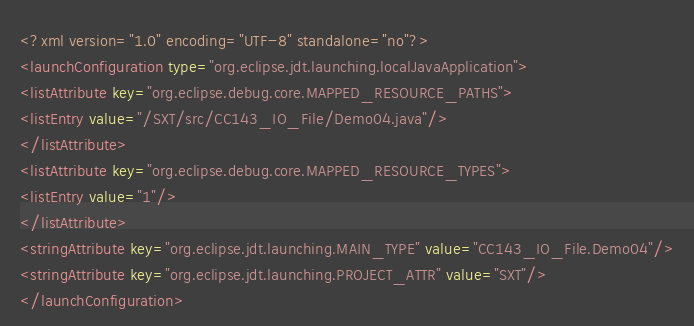Convert code to text. <code><loc_0><loc_0><loc_500><loc_500><_XML_><?xml version="1.0" encoding="UTF-8" standalone="no"?>
<launchConfiguration type="org.eclipse.jdt.launching.localJavaApplication">
<listAttribute key="org.eclipse.debug.core.MAPPED_RESOURCE_PATHS">
<listEntry value="/SXT/src/CC143_IO_File/Demo04.java"/>
</listAttribute>
<listAttribute key="org.eclipse.debug.core.MAPPED_RESOURCE_TYPES">
<listEntry value="1"/>
</listAttribute>
<stringAttribute key="org.eclipse.jdt.launching.MAIN_TYPE" value="CC143_IO_File.Demo04"/>
<stringAttribute key="org.eclipse.jdt.launching.PROJECT_ATTR" value="SXT"/>
</launchConfiguration>
</code> 